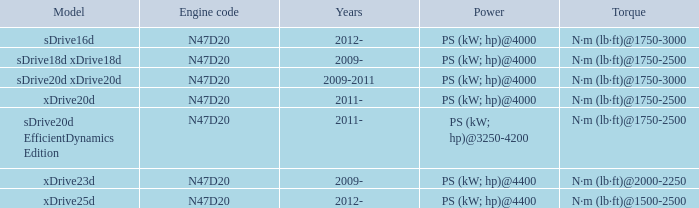What is the torque of the xdrive20d model, which has a power of ps (kw; hp)@4000? N·m (lb·ft)@1750-2500. 